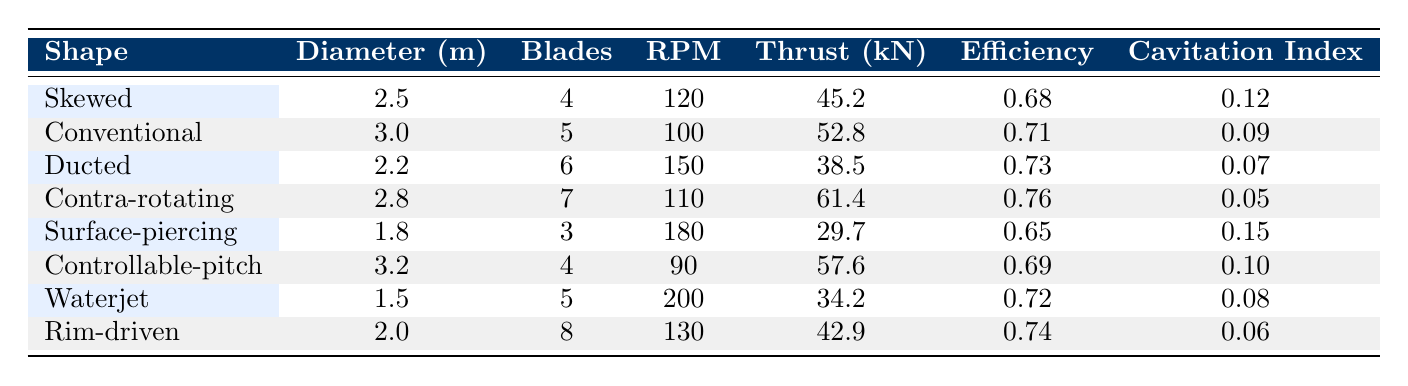What is the thrust produced by the Contra-rotating propeller? The Contra-rotating propeller's thrust is listed in the table under the thrust column. It shows a value of 61.4 kN.
Answer: 61.4 kN How many blades does the Ducted propeller have? To find the number of blades for the Ducted propeller, I can simply look up the corresponding value in the blades column for the Ducted row. It shows 6 blades.
Answer: 6 blades What is the average diameter of all the propellers tested? To find the average diameter, sum the diameters: (2.5 + 3.0 + 2.2 + 2.8 + 1.8 + 3.2 + 1.5 + 2.0) = 19.0 m. There are 8 propellers, so the average diameter is 19.0 m / 8 = 2.375 m.
Answer: 2.375 m Is the efficiency of the Surface-piercing propeller greater than that of the Skewed propeller? The efficiency of the Surface-piercing propeller is 0.65, and for the Skewed propeller, it is 0.68. Since 0.65 is less than 0.68, the statement is false.
Answer: No Which propeller has the lowest cavitation index? By examining the cavitation index column, I find the values for each propeller. The lowest value is 0.05, which is for the Contra-rotating propeller.
Answer: Contra-rotating What is the difference in torque between the Conventional and Controllable-pitch propellers? The torque for the Conventional propeller is 23.1 kNm, while for the Controllable-pitch it is 26.8 kNm. The difference is calculated as 26.8 kNm - 23.1 kNm = 3.7 kNm.
Answer: 3.7 kNm Are more blades generally associated with higher thrust in the designs provided? To determine this, I would need to analyze the thrust values and the number of blades side by side. Generally, more blades tend to contribute to higher thrust, but not always. Examining the values, the Maximum thrust is 61.4 kN with 7 blades, but not all propellers fit this pattern. Therefore, it can't be universally stated.
Answer: No Which test facility had the highest thrust recorded? Looking at the thrust values, the highest thrust of 61.4 kN corresponds to the Contra-rotating propeller tested at INSEAN. Hence, INSEAN had the highest recorded thrust.
Answer: INSEAN 